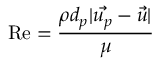Convert formula to latex. <formula><loc_0><loc_0><loc_500><loc_500>R e = \frac { \rho d _ { p } | \vec { u _ { p } } - \vec { u } | } { \mu }</formula> 